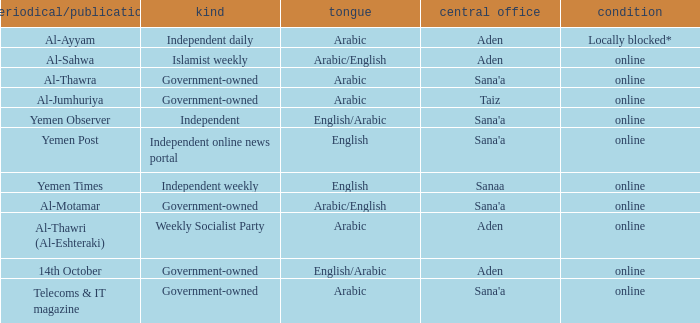What is Headquarter, when Type is Government-Owned, and when Newspaper/Magazine is Al-Jumhuriya? Taiz. 